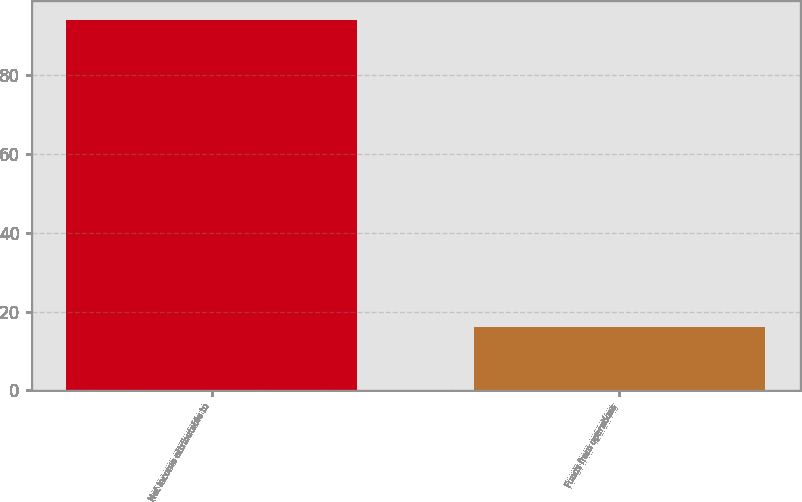<chart> <loc_0><loc_0><loc_500><loc_500><bar_chart><fcel>Net income attributable to<fcel>Funds from operations<nl><fcel>94<fcel>16<nl></chart> 